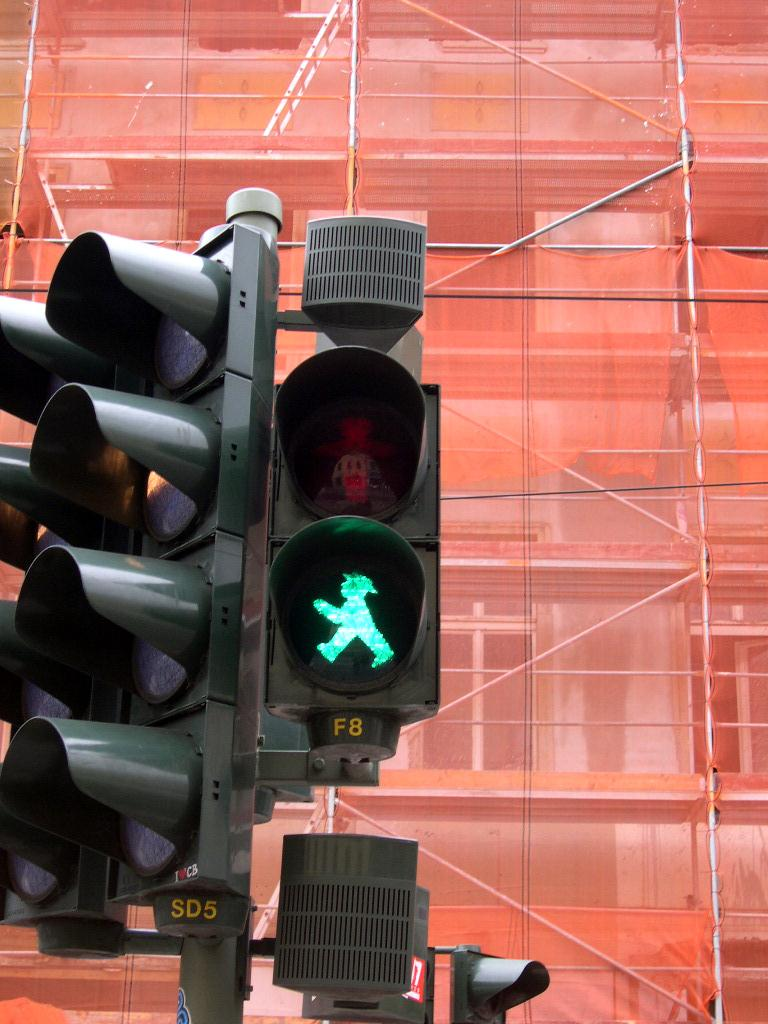<image>
Present a compact description of the photo's key features. A pedestrian traffic light shows a little green person and the code F8 under it. 